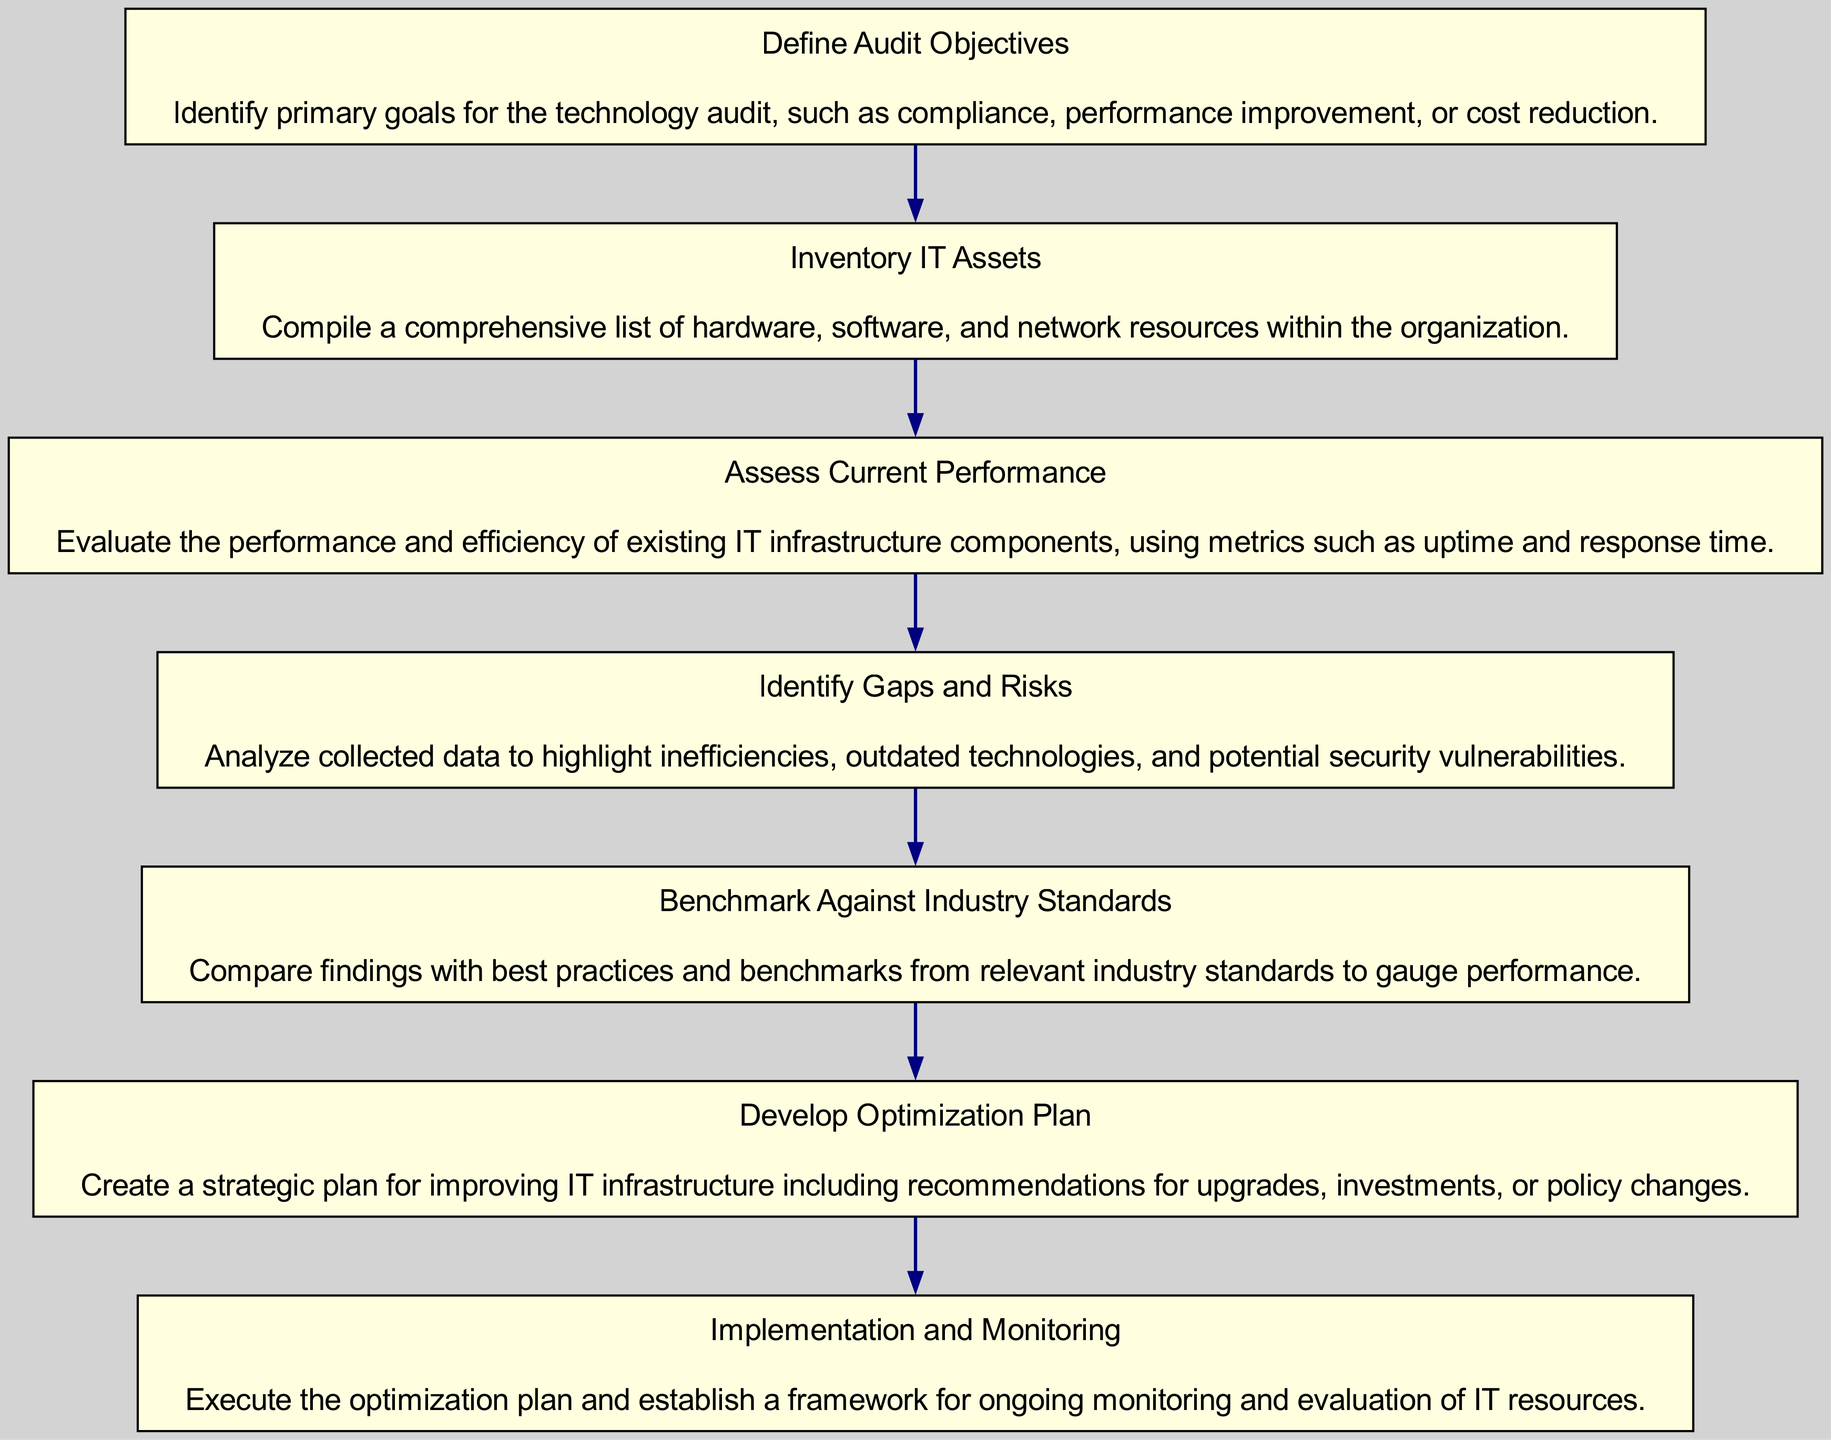What is the first step in the technology audit process? The first step in the process is to "Define Audit Objectives". This is indicated as the starting node of the flow chart, which outlines the initial action required for conducting a technology audit.
Answer: Define Audit Objectives How many nodes are present in the diagram? The diagram includes seven nodes, each representing distinct steps in the technology audit process, from defining objectives to implementation and monitoring.
Answer: Seven Which step follows "Identify Gaps and Risks"? After "Identify Gaps and Risks," the next step is "Benchmark Against Industry Standards," which is linked directly as the subsequent node in the flow of the diagram.
Answer: Benchmark Against Industry Standards What is the primary goal of the "Inventory IT Assets"? The primary goal of "Inventory IT Assets" is to compile a comprehensive list of hardware, software, and network resources within the organization, as defined in its description.
Answer: Compile a comprehensive list How does the flow chart indicate the relationship between "Assess Current Performance" and "Identify Gaps and Risks"? The flow chart shows a direct connection from "Assess Current Performance" to "Identify Gaps and Risks," indicating that after assessing performance, the next logical step is to analyze the collected data for inefficiencies and risks.
Answer: Direct connection What is the purpose of the final node "Implementation and Monitoring"? The purpose of "Implementation and Monitoring" is to execute the optimization plan and establish a framework for ongoing monitoring and evaluation of IT resources, ensuring continuous improvement.
Answer: Execute the optimization plan Which node serves as the basis for developing an optimization plan? The "Identify Gaps and Risks" node serves as the basis for developing an optimization plan since it identifies inefficiencies that need to be addressed.
Answer: Identify Gaps and Risks What does the audit process compare findings against in "Benchmark Against Industry Standards"? The audit process compares findings against best practices and benchmarks from relevant industry standards to gauge performance and identify areas for improvement.
Answer: Best practices and benchmarks 